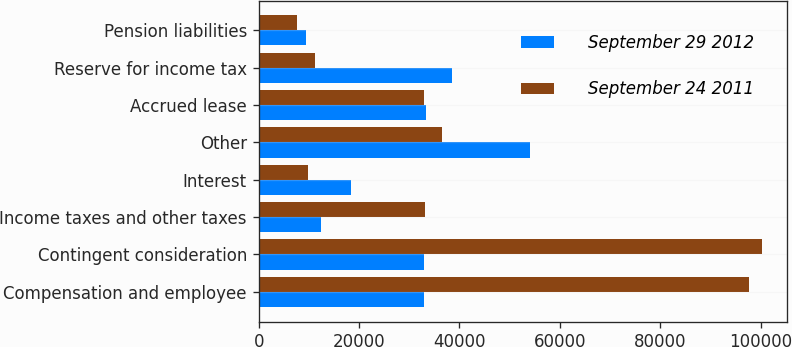Convert chart. <chart><loc_0><loc_0><loc_500><loc_500><stacked_bar_chart><ecel><fcel>Compensation and employee<fcel>Contingent consideration<fcel>Income taxes and other taxes<fcel>Interest<fcel>Other<fcel>Accrued lease<fcel>Reserve for income tax<fcel>Pension liabilities<nl><fcel>September 29 2012<fcel>32958<fcel>32958<fcel>12424<fcel>18422<fcel>53981<fcel>33256<fcel>38518<fcel>9397<nl><fcel>September 24 2011<fcel>97747<fcel>100255<fcel>33070<fcel>9802<fcel>36504<fcel>32846<fcel>11202<fcel>7714<nl></chart> 